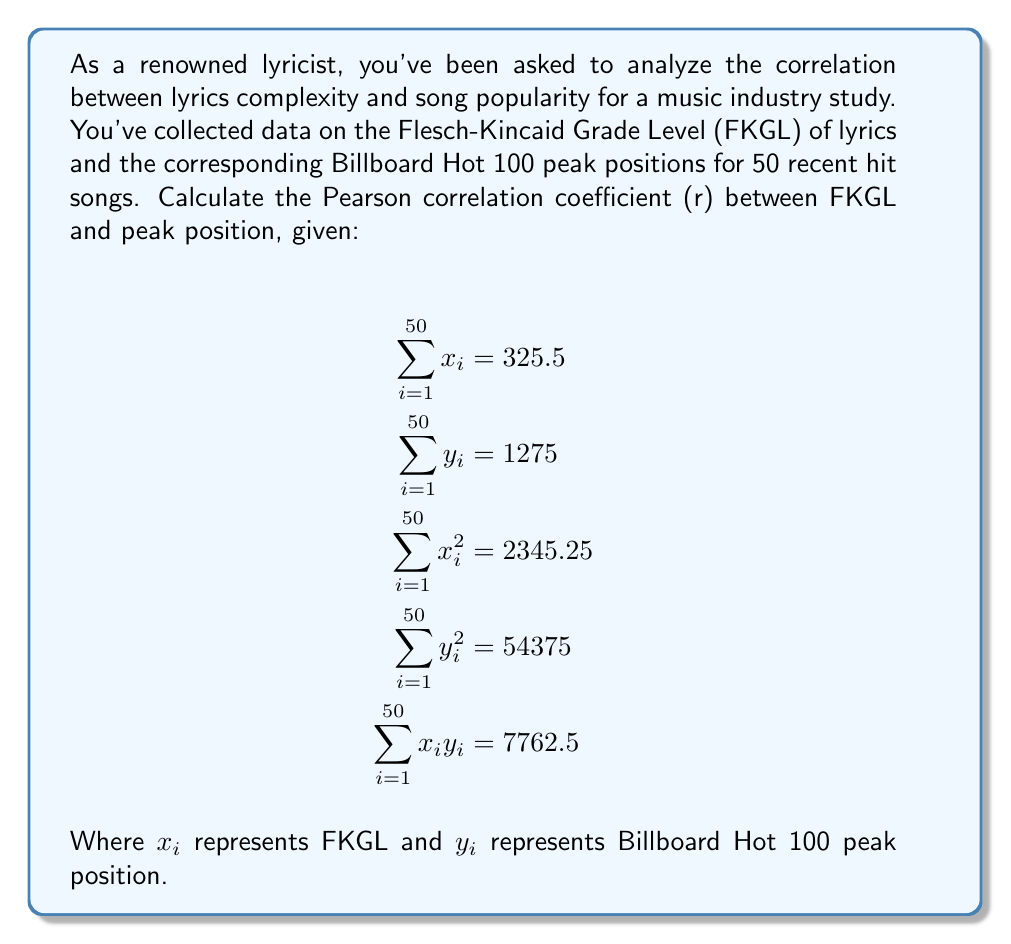Can you solve this math problem? To calculate the Pearson correlation coefficient (r), we'll use the formula:

$$r = \frac{n\sum x_iy_i - \sum x_i \sum y_i}{\sqrt{[n\sum x_i^2 - (\sum x_i)^2][n\sum y_i^2 - (\sum y_i)^2]}}$$

Where n is the number of data points (50 in this case).

Step 1: Calculate $n\sum x_iy_i$
$50 \times 7762.5 = 388125$

Step 2: Calculate $\sum x_i \sum y_i$
$325.5 \times 1275 = 415012.5$

Step 3: Calculate the numerator
$388125 - 415012.5 = -26887.5$

Step 4: Calculate $n\sum x_i^2$
$50 \times 2345.25 = 117262.5$

Step 5: Calculate $(\sum x_i)^2$
$325.5^2 = 105950.25$

Step 6: Calculate $n\sum y_i^2$
$50 \times 54375 = 2718750$

Step 7: Calculate $(\sum y_i)^2$
$1275^2 = 1625625$

Step 8: Calculate the denominator
$\sqrt{(117262.5 - 105950.25)(2718750 - 1625625)}$
$= \sqrt{11312.25 \times 1093125}$
$= \sqrt{12365390156.25}$
$= 111199.96$

Step 9: Calculate r
$r = \frac{-26887.5}{111199.96} = -0.2418$
Answer: $r \approx -0.2418$ 